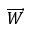<formula> <loc_0><loc_0><loc_500><loc_500>\overrightarrow { W }</formula> 